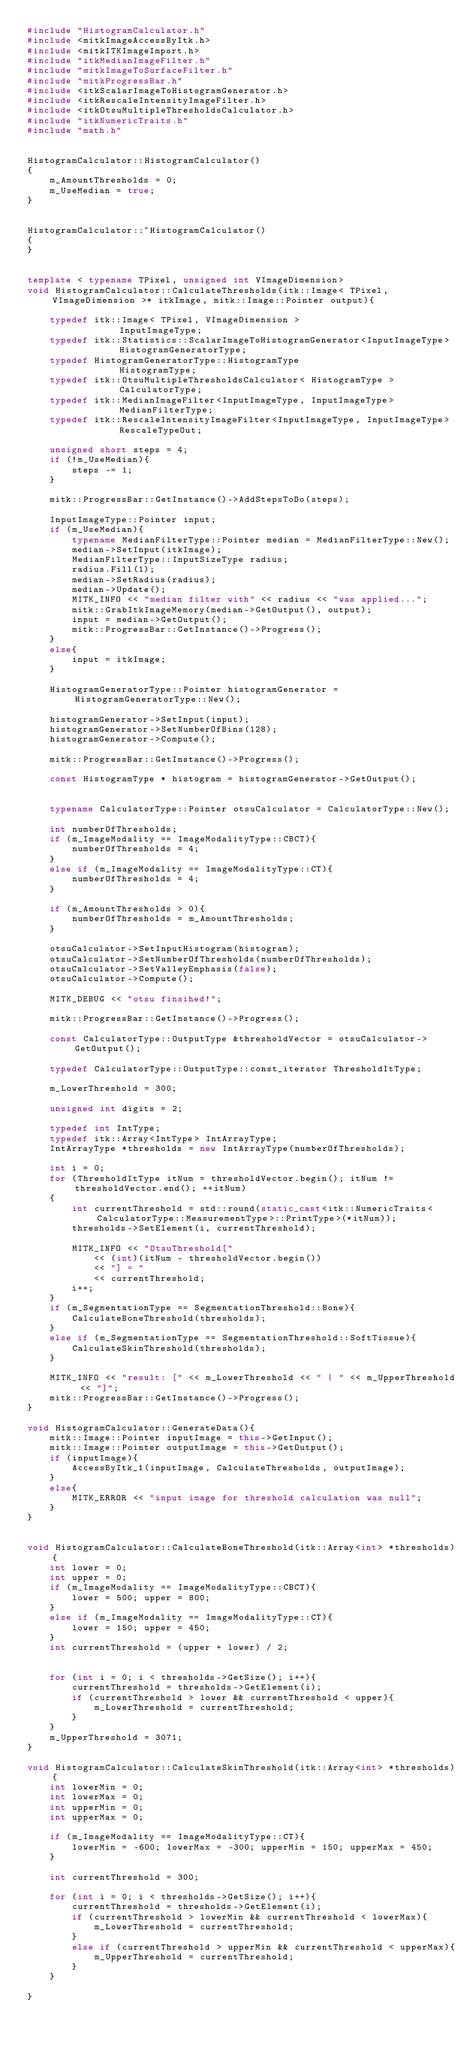Convert code to text. <code><loc_0><loc_0><loc_500><loc_500><_C++_>#include "HistogramCalculator.h"
#include <mitkImageAccessByItk.h>
#include <mitkITKImageImport.h>
#include "itkMedianImageFilter.h"
#include "mitkImageToSurfaceFilter.h"
#include "mitkProgressBar.h"
#include <itkScalarImageToHistogramGenerator.h>
#include <itkRescaleIntensityImageFilter.h>
#include <itkOtsuMultipleThresholdsCalculator.h>
#include "itkNumericTraits.h"
#include "math.h"


HistogramCalculator::HistogramCalculator()
{
	m_AmountThresholds = 0;
	m_UseMedian = true;
}


HistogramCalculator::~HistogramCalculator()
{
}


template < typename TPixel, unsigned int VImageDimension>
void HistogramCalculator::CalculateThresholds(itk::Image< TPixel, VImageDimension >* itkImage, mitk::Image::Pointer output){

	typedef itk::Image< TPixel, VImageDimension >									InputImageType;
	typedef itk::Statistics::ScalarImageToHistogramGenerator<InputImageType>		HistogramGeneratorType;
	typedef HistogramGeneratorType::HistogramType									HistogramType;
	typedef itk::OtsuMultipleThresholdsCalculator< HistogramType >					CalculatorType;
	typedef itk::MedianImageFilter<InputImageType, InputImageType>					MedianFilterType;
	typedef itk::RescaleIntensityImageFilter<InputImageType, InputImageType>		RescaleTypeOut;

	unsigned short steps = 4;
	if (!m_UseMedian){
		steps -= 1;
	}

	mitk::ProgressBar::GetInstance()->AddStepsToDo(steps);

	InputImageType::Pointer input;
	if (m_UseMedian){
		typename MedianFilterType::Pointer median = MedianFilterType::New();
		median->SetInput(itkImage);
		MedianFilterType::InputSizeType radius;
		radius.Fill(1);
		median->SetRadius(radius);
		median->Update();
		MITK_INFO << "median filter with" << radius << "was applied...";
		mitk::GrabItkImageMemory(median->GetOutput(), output);
		input = median->GetOutput();
		mitk::ProgressBar::GetInstance()->Progress();
	}
	else{
		input = itkImage;
	}

	HistogramGeneratorType::Pointer histogramGenerator = HistogramGeneratorType::New();

	histogramGenerator->SetInput(input);
	histogramGenerator->SetNumberOfBins(128);
	histogramGenerator->Compute();

	mitk::ProgressBar::GetInstance()->Progress();

	const HistogramType * histogram = histogramGenerator->GetOutput();


	typename CalculatorType::Pointer otsuCalculator = CalculatorType::New();

	int numberOfThresholds;
	if (m_ImageModality == ImageModalityType::CBCT){
		numberOfThresholds = 4;
	}
	else if (m_ImageModality == ImageModalityType::CT){
		numberOfThresholds = 4;
	}

	if (m_AmountThresholds > 0){
		numberOfThresholds = m_AmountThresholds;
	}

	otsuCalculator->SetInputHistogram(histogram);
	otsuCalculator->SetNumberOfThresholds(numberOfThresholds);
	otsuCalculator->SetValleyEmphasis(false);
	otsuCalculator->Compute();

	MITK_DEBUG << "otsu finsihed!";

	mitk::ProgressBar::GetInstance()->Progress();

	const CalculatorType::OutputType &thresholdVector = otsuCalculator->GetOutput();

	typedef CalculatorType::OutputType::const_iterator ThresholdItType;

	m_LowerThreshold = 300;

	unsigned int digits = 2;

	typedef int IntType;
	typedef itk::Array<IntType>	IntArrayType;
	IntArrayType *thresholds = new IntArrayType(numberOfThresholds);

	int i = 0;
	for (ThresholdItType itNum = thresholdVector.begin(); itNum != thresholdVector.end(); ++itNum)
	{
		int currentThreshold = std::round(static_cast<itk::NumericTraits<CalculatorType::MeasurementType>::PrintType>(*itNum));
		thresholds->SetElement(i, currentThreshold);

		MITK_INFO << "OtsuThreshold["
			<< (int)(itNum - thresholdVector.begin())
			<< "] = "
			<< currentThreshold;
		i++;
	}
	if (m_SegmentationType == SegmentationThreshold::Bone){
		CalculateBoneThreshold(thresholds);
	}
	else if (m_SegmentationType == SegmentationThreshold::SoftTissue){
		CalculateSkinThreshold(thresholds);
	}

	MITK_INFO << "result: [" << m_LowerThreshold << " | " << m_UpperThreshold << "]";
	mitk::ProgressBar::GetInstance()->Progress();
}

void HistogramCalculator::GenerateData(){
	mitk::Image::Pointer inputImage = this->GetInput();
	mitk::Image::Pointer outputImage = this->GetOutput();
	if (inputImage){
		AccessByItk_1(inputImage, CalculateThresholds, outputImage);
	}
	else{
		MITK_ERROR << "input image for threshold calculation was null";
	}
}


void HistogramCalculator::CalculateBoneThreshold(itk::Array<int> *thresholds){
	int lower = 0;
	int upper = 0;
	if (m_ImageModality == ImageModalityType::CBCT){
		lower = 500; upper = 800;
	}
	else if (m_ImageModality == ImageModalityType::CT){
		lower = 150; upper = 450;
	}
	int currentThreshold = (upper + lower) / 2;
	

	for (int i = 0; i < thresholds->GetSize(); i++){
		currentThreshold = thresholds->GetElement(i);
		if (currentThreshold > lower && currentThreshold < upper){
			m_LowerThreshold = currentThreshold;
		}
	}
	m_UpperThreshold = 3071;
}

void HistogramCalculator::CalculateSkinThreshold(itk::Array<int> *thresholds){
	int lowerMin = 0;
	int lowerMax = 0;
	int upperMin = 0;
	int upperMax = 0;

	if (m_ImageModality == ImageModalityType::CT){
		lowerMin = -600; lowerMax = -300; upperMin = 150; upperMax = 450;
	}

	int currentThreshold = 300;

	for (int i = 0; i < thresholds->GetSize(); i++){
		currentThreshold = thresholds->GetElement(i);
		if (currentThreshold > lowerMin && currentThreshold < lowerMax){
			m_LowerThreshold = currentThreshold;
		}
		else if (currentThreshold > upperMin && currentThreshold < upperMax){
			m_UpperThreshold = currentThreshold;
		}
	}

}</code> 